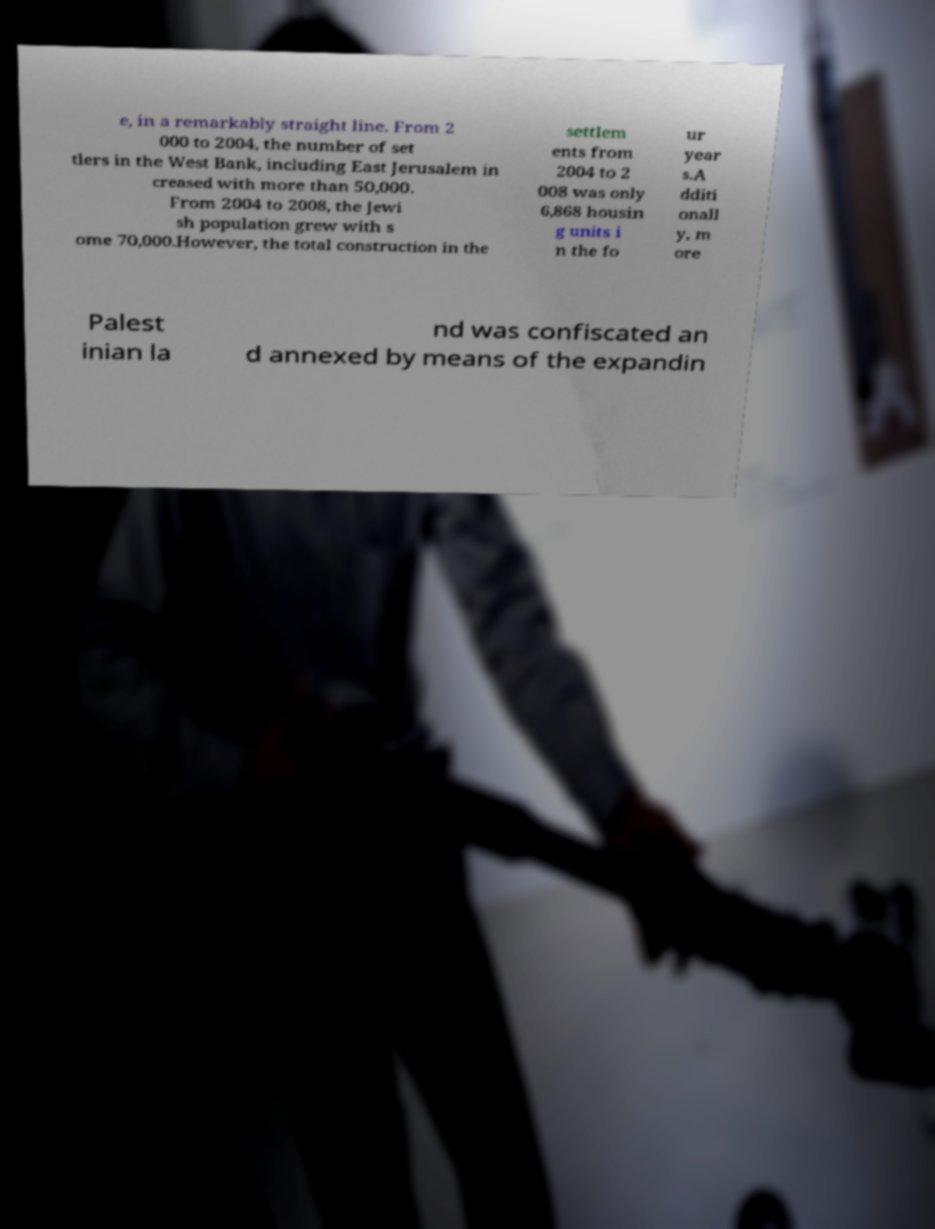Please read and relay the text visible in this image. What does it say? e, in a remarkably straight line. From 2 000 to 2004, the number of set tlers in the West Bank, including East Jerusalem in creased with more than 50,000. From 2004 to 2008, the Jewi sh population grew with s ome 70,000.However, the total construction in the settlem ents from 2004 to 2 008 was only 6,868 housin g units i n the fo ur year s.A dditi onall y, m ore Palest inian la nd was confiscated an d annexed by means of the expandin 